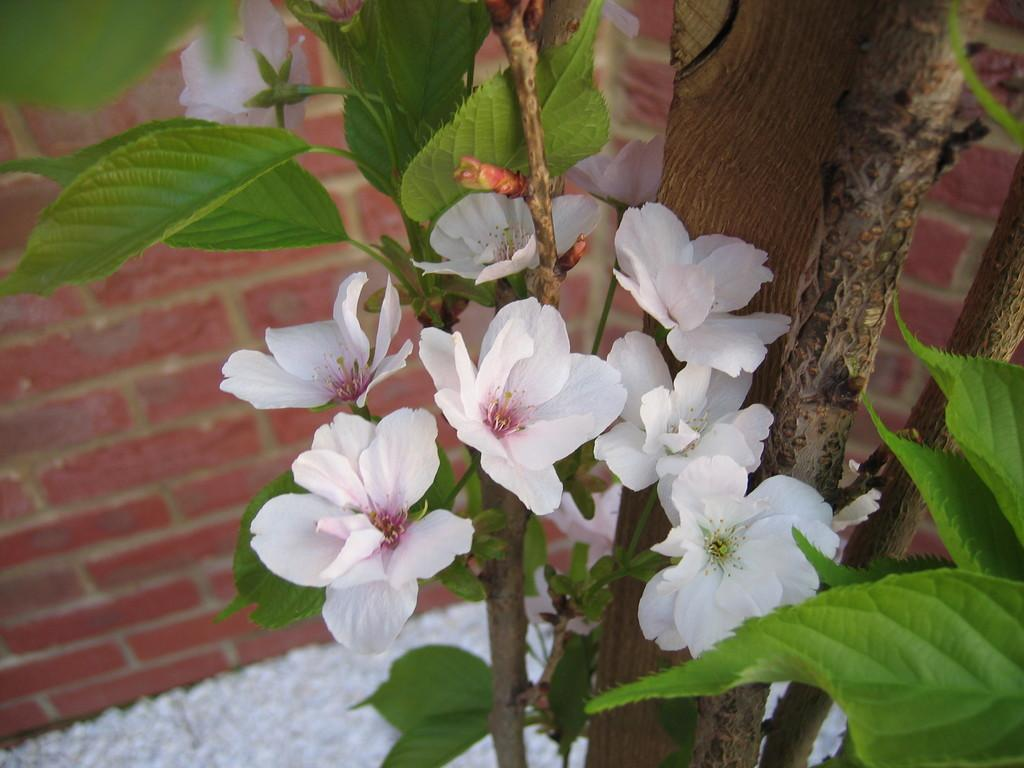What type of plant can be seen in the image? There is a tree in the image. What parts of the tree are visible? Leaves and flowers are visible near the tree. What is located behind the tree in the image? The wall is visible behind the tree. What type of chalk is being used in the discussion near the tree? There is no chalk or discussion present in the image; it only features a tree, leaves, flowers, and a wall. 